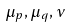<formula> <loc_0><loc_0><loc_500><loc_500>\mu _ { p } , \mu _ { q } , \nu</formula> 